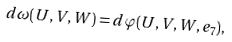<formula> <loc_0><loc_0><loc_500><loc_500>d \omega ( U , V , W ) = d \varphi ( U , V , W , e _ { 7 } ) ,</formula> 